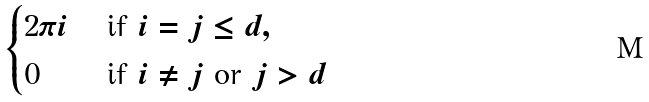Convert formula to latex. <formula><loc_0><loc_0><loc_500><loc_500>\begin{cases} 2 \pi i & \text { if $i=j\leq d$} , \\ 0 & \text { if $i\ne j$ or $j>d$} \end{cases}</formula> 